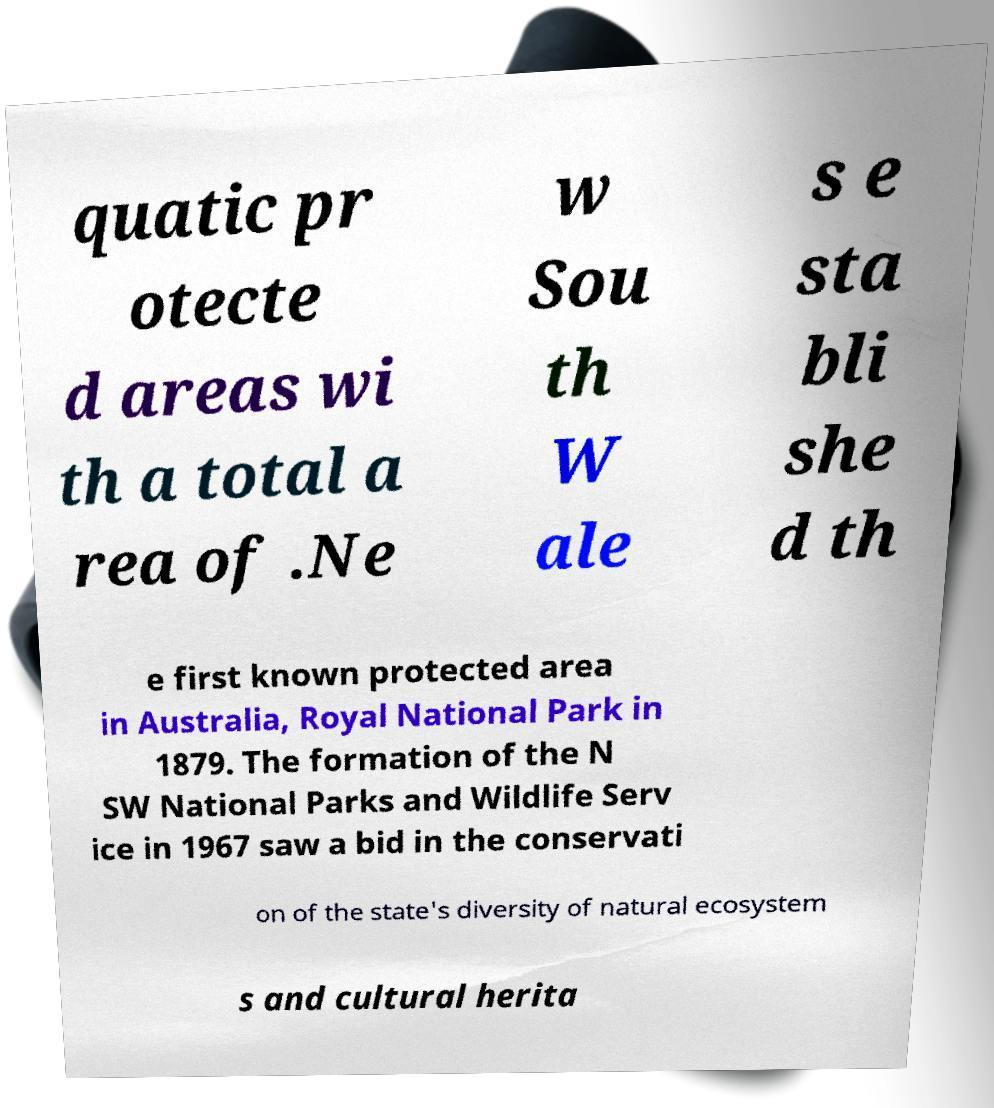Can you accurately transcribe the text from the provided image for me? quatic pr otecte d areas wi th a total a rea of .Ne w Sou th W ale s e sta bli she d th e first known protected area in Australia, Royal National Park in 1879. The formation of the N SW National Parks and Wildlife Serv ice in 1967 saw a bid in the conservati on of the state's diversity of natural ecosystem s and cultural herita 